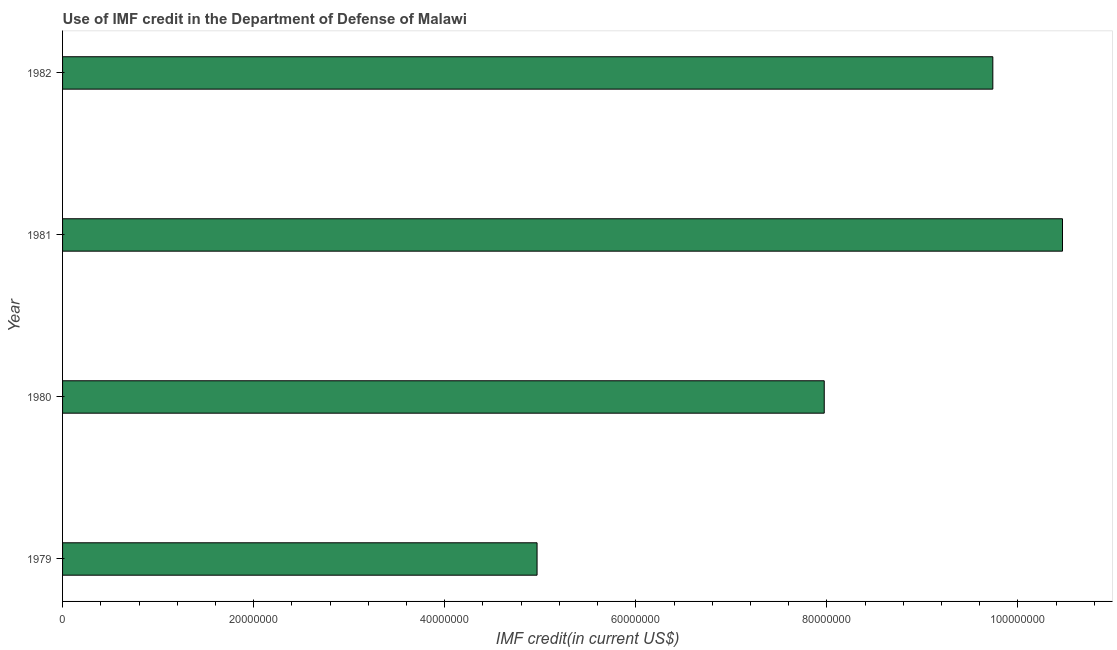Does the graph contain any zero values?
Offer a very short reply. No. Does the graph contain grids?
Make the answer very short. No. What is the title of the graph?
Offer a terse response. Use of IMF credit in the Department of Defense of Malawi. What is the label or title of the X-axis?
Your answer should be very brief. IMF credit(in current US$). What is the use of imf credit in dod in 1980?
Keep it short and to the point. 7.97e+07. Across all years, what is the maximum use of imf credit in dod?
Your answer should be compact. 1.05e+08. Across all years, what is the minimum use of imf credit in dod?
Provide a short and direct response. 4.97e+07. In which year was the use of imf credit in dod maximum?
Offer a very short reply. 1981. In which year was the use of imf credit in dod minimum?
Your answer should be very brief. 1979. What is the sum of the use of imf credit in dod?
Your answer should be very brief. 3.31e+08. What is the difference between the use of imf credit in dod in 1979 and 1982?
Keep it short and to the point. -4.77e+07. What is the average use of imf credit in dod per year?
Make the answer very short. 8.29e+07. What is the median use of imf credit in dod?
Give a very brief answer. 8.85e+07. In how many years, is the use of imf credit in dod greater than 80000000 US$?
Offer a terse response. 2. What is the ratio of the use of imf credit in dod in 1980 to that in 1981?
Your answer should be compact. 0.76. Is the use of imf credit in dod in 1979 less than that in 1980?
Your answer should be very brief. Yes. What is the difference between the highest and the second highest use of imf credit in dod?
Keep it short and to the point. 7.29e+06. Is the sum of the use of imf credit in dod in 1979 and 1982 greater than the maximum use of imf credit in dod across all years?
Offer a very short reply. Yes. What is the difference between the highest and the lowest use of imf credit in dod?
Your answer should be compact. 5.50e+07. In how many years, is the use of imf credit in dod greater than the average use of imf credit in dod taken over all years?
Offer a terse response. 2. Are all the bars in the graph horizontal?
Offer a very short reply. Yes. How many years are there in the graph?
Provide a succinct answer. 4. What is the difference between two consecutive major ticks on the X-axis?
Your response must be concise. 2.00e+07. What is the IMF credit(in current US$) in 1979?
Give a very brief answer. 4.97e+07. What is the IMF credit(in current US$) of 1980?
Your response must be concise. 7.97e+07. What is the IMF credit(in current US$) of 1981?
Provide a succinct answer. 1.05e+08. What is the IMF credit(in current US$) in 1982?
Your answer should be compact. 9.74e+07. What is the difference between the IMF credit(in current US$) in 1979 and 1980?
Keep it short and to the point. -3.01e+07. What is the difference between the IMF credit(in current US$) in 1979 and 1981?
Provide a succinct answer. -5.50e+07. What is the difference between the IMF credit(in current US$) in 1979 and 1982?
Ensure brevity in your answer.  -4.77e+07. What is the difference between the IMF credit(in current US$) in 1980 and 1981?
Offer a very short reply. -2.49e+07. What is the difference between the IMF credit(in current US$) in 1980 and 1982?
Offer a very short reply. -1.76e+07. What is the difference between the IMF credit(in current US$) in 1981 and 1982?
Offer a terse response. 7.29e+06. What is the ratio of the IMF credit(in current US$) in 1979 to that in 1980?
Your answer should be compact. 0.62. What is the ratio of the IMF credit(in current US$) in 1979 to that in 1981?
Provide a succinct answer. 0.47. What is the ratio of the IMF credit(in current US$) in 1979 to that in 1982?
Provide a succinct answer. 0.51. What is the ratio of the IMF credit(in current US$) in 1980 to that in 1981?
Provide a succinct answer. 0.76. What is the ratio of the IMF credit(in current US$) in 1980 to that in 1982?
Offer a terse response. 0.82. What is the ratio of the IMF credit(in current US$) in 1981 to that in 1982?
Offer a terse response. 1.07. 